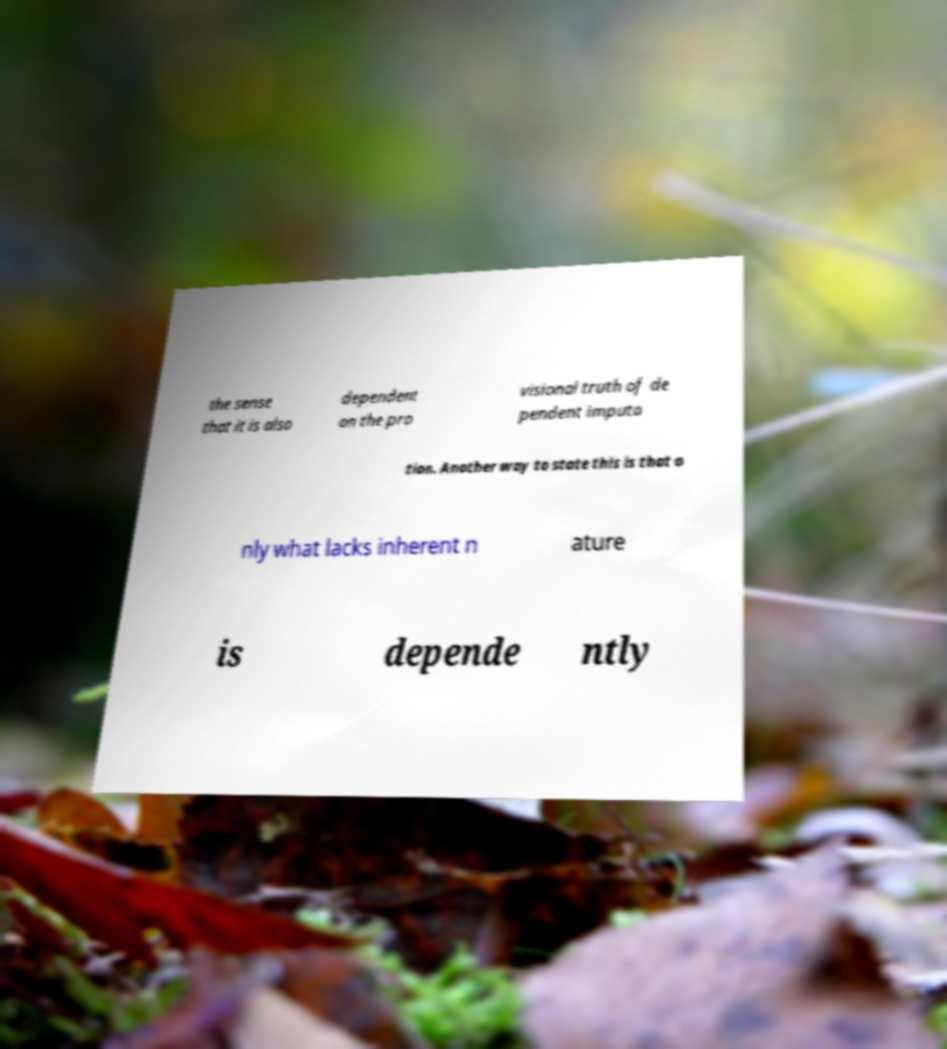Please read and relay the text visible in this image. What does it say? the sense that it is also dependent on the pro visional truth of de pendent imputa tion. Another way to state this is that o nly what lacks inherent n ature is depende ntly 